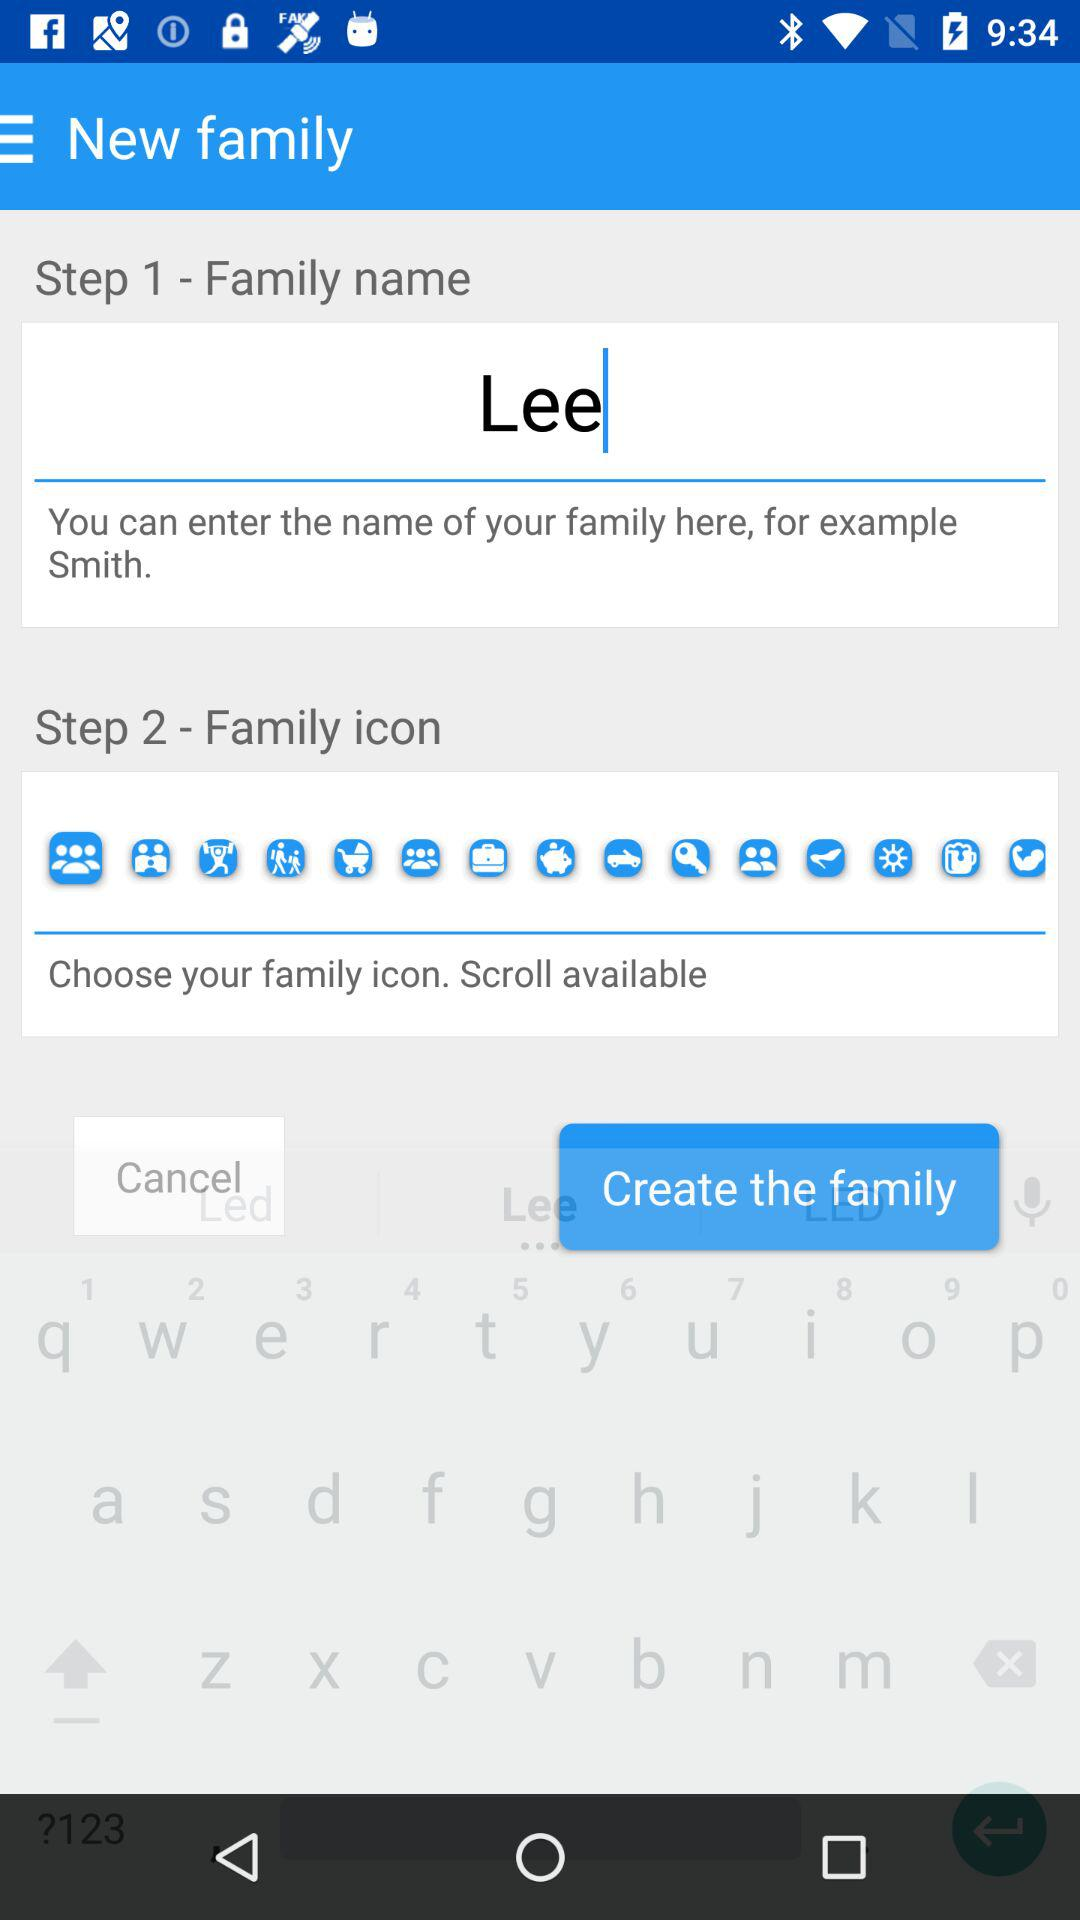How many steps are there to create a family?
Answer the question using a single word or phrase. 2 